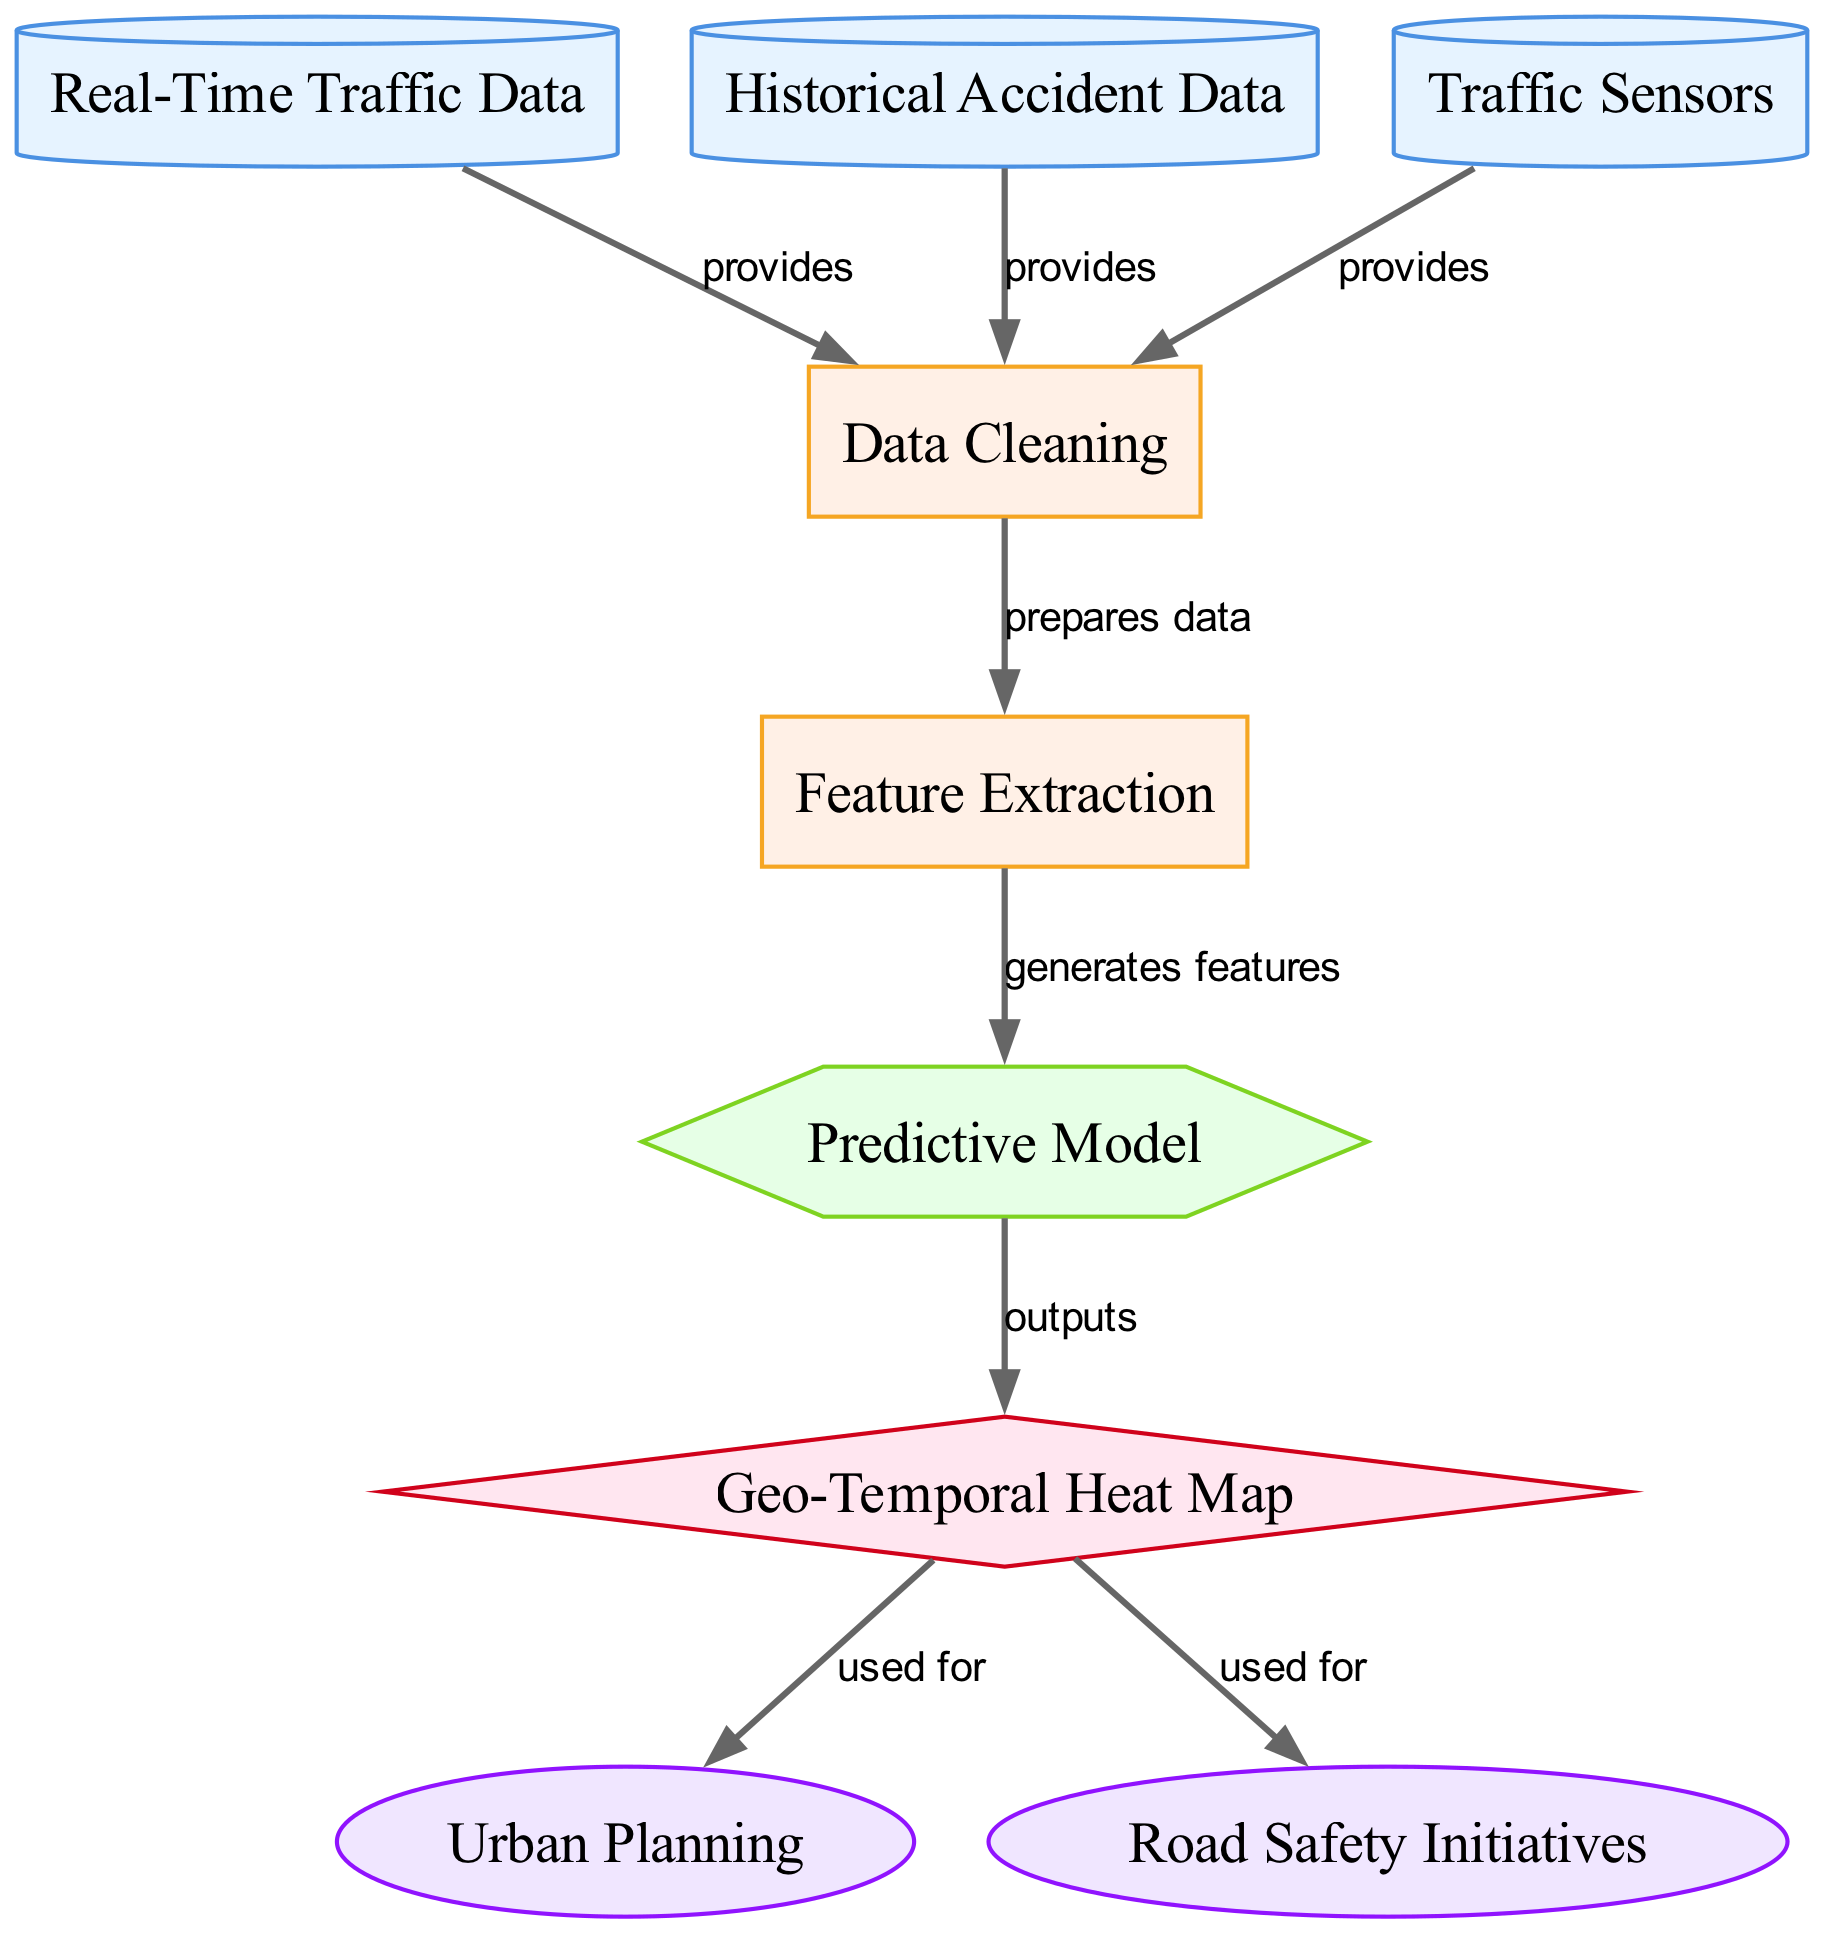What's the total number of nodes in the diagram? The diagram contains a total of 9 nodes, which include data sources, processes, a predictive model, a visualization, and applications.
Answer: 9 Which data source provides real-time traffic data? In the diagram, the node labeled "Real-Time Traffic Data" is identified as a data source providing input for the process of data cleaning.
Answer: Real-Time Traffic Data What process comes after data cleaning in the flow? The process that follows "Data Cleaning" is "Feature Extraction," where extracted features are generated for the predictive model.
Answer: Feature Extraction Which applications use the Geo-Temporal Heat Map? Both "Urban Planning" and "Road Safety Initiatives" are applications that utilize the outputs from the "Geo-Temporal Heat Map."
Answer: Urban Planning and Road Safety Initiatives What type of machine learning model is being utilized in this diagram? The diagram specifically employs a "Predictive Model" which utilizes real-time and historical data to predict future traffic conditions and accident hotspots.
Answer: Predictive Model How many edges connect the "Real-Time Traffic Data" to other nodes? The "Real-Time Traffic Data" node connects to two other nodes via edges, indicating it provides input to the data cleaning process.
Answer: 2 What does the predictive model output in the diagram? The "Predictive Model" outputs a "Geo-Temporal Heat Map," which visualizes potential traffic congestion and accident hotspots.
Answer: Geo-Temporal Heat Map What is the first step in the data processing flow? The first step is "Data Cleaning," where the data sources such as real-time traffic data, historical accident data, and traffic sensor data are prepared for further processing.
Answer: Data Cleaning Which node represents the visualization technique used for traffic prediction? The node labeled "Geo-Temporal Heat Map" represents the visualization technique in the diagram to illustrate predicted traffic conditions and potential accident hotspots.
Answer: Geo-Temporal Heat Map 